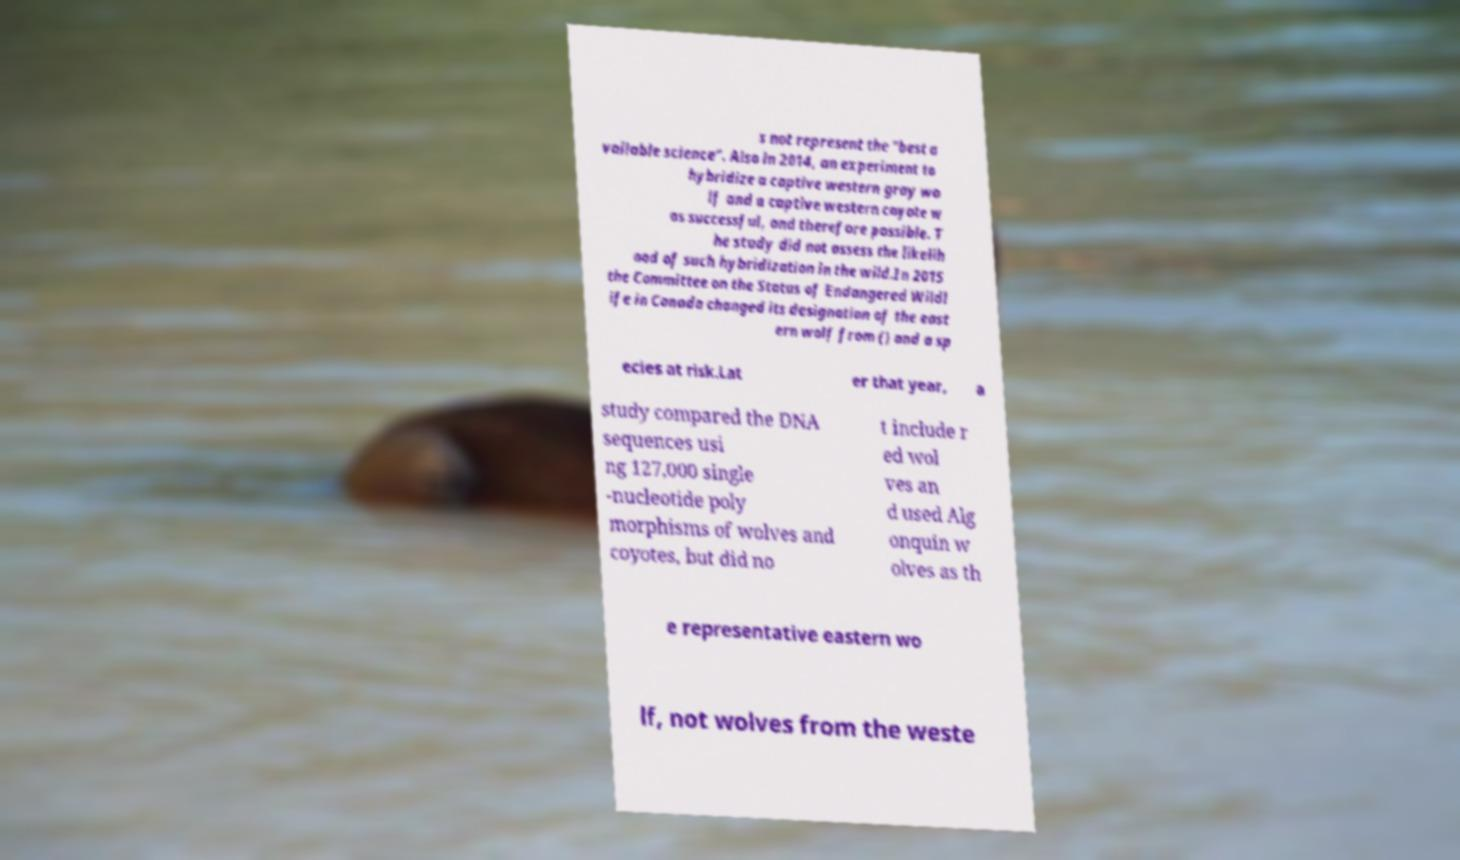Please identify and transcribe the text found in this image. s not represent the "best a vailable science". Also in 2014, an experiment to hybridize a captive western gray wo lf and a captive western coyote w as successful, and therefore possible. T he study did not assess the likelih ood of such hybridization in the wild.In 2015 the Committee on the Status of Endangered Wildl ife in Canada changed its designation of the east ern wolf from () and a sp ecies at risk.Lat er that year, a study compared the DNA sequences usi ng 127,000 single -nucleotide poly morphisms of wolves and coyotes, but did no t include r ed wol ves an d used Alg onquin w olves as th e representative eastern wo lf, not wolves from the weste 